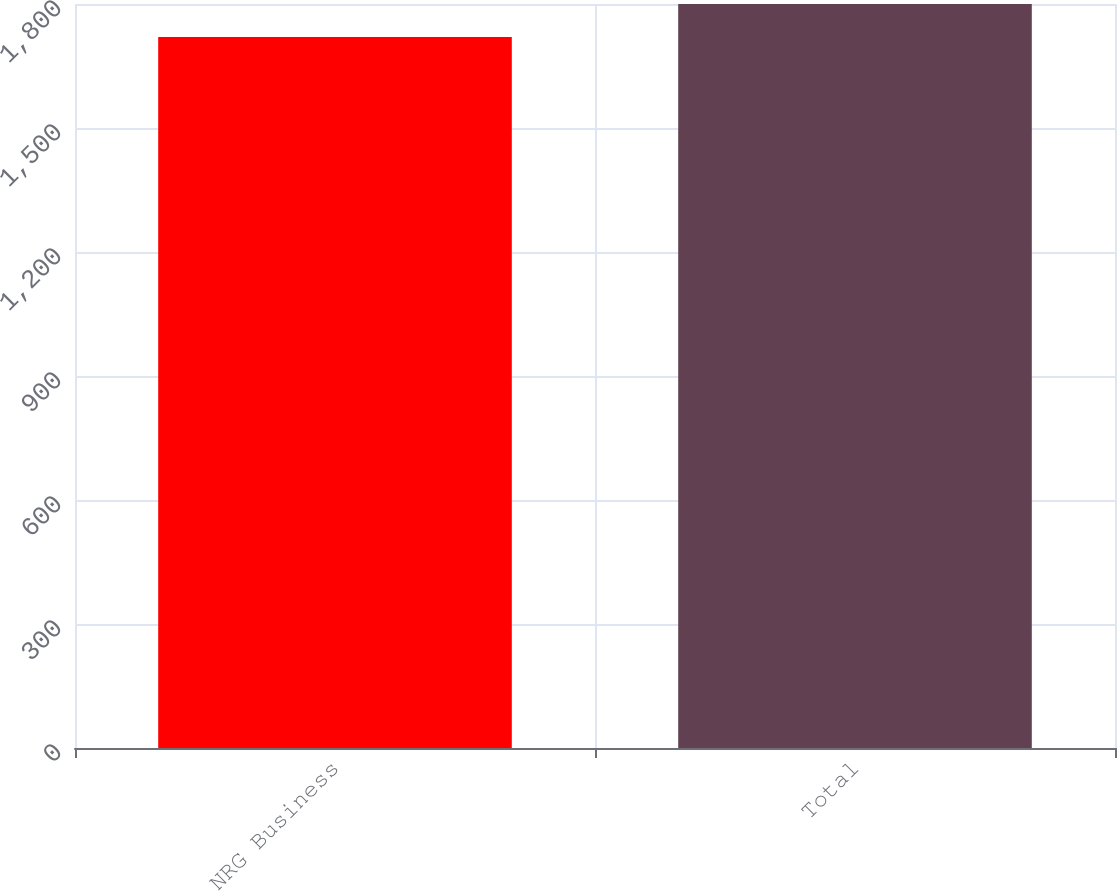Convert chart. <chart><loc_0><loc_0><loc_500><loc_500><bar_chart><fcel>NRG Business<fcel>Total<nl><fcel>1720<fcel>1800<nl></chart> 